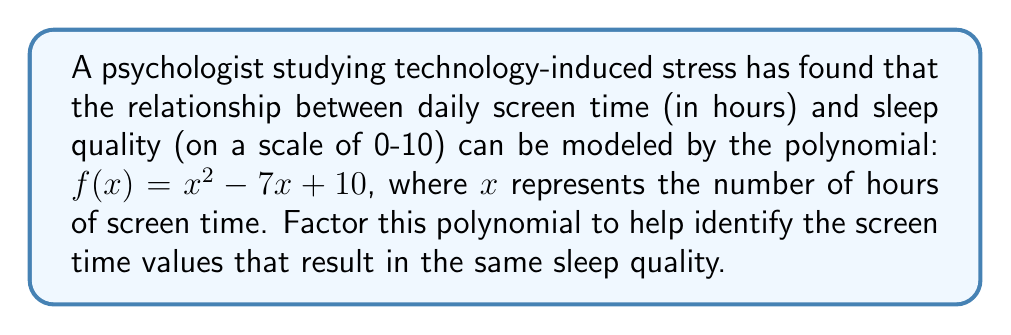Could you help me with this problem? To factor this quadratic polynomial, we'll use the following steps:

1) First, identify the coefficients:
   $a = 1$, $b = -7$, and $c = 10$

2) Calculate the discriminant using the formula $b^2 - 4ac$:
   $(-7)^2 - 4(1)(10) = 49 - 40 = 9$

3) Since the discriminant is a perfect square (9), this polynomial can be factored.

4) Use the quadratic formula to find the roots:
   $x = \frac{-b \pm \sqrt{b^2 - 4ac}}{2a}$

   $x = \frac{7 \pm \sqrt{9}}{2} = \frac{7 \pm 3}{2}$

5) This gives us two roots:
   $x_1 = \frac{7 + 3}{2} = 5$ and $x_2 = \frac{7 - 3}{2} = 2$

6) The factored form of the polynomial is:
   $f(x) = (x - x_1)(x - x_2) = (x - 5)(x - 2)$

Therefore, the factored form of $x^2 - 7x + 10$ is $(x - 5)(x - 2)$.
Answer: $(x - 5)(x - 2)$ 